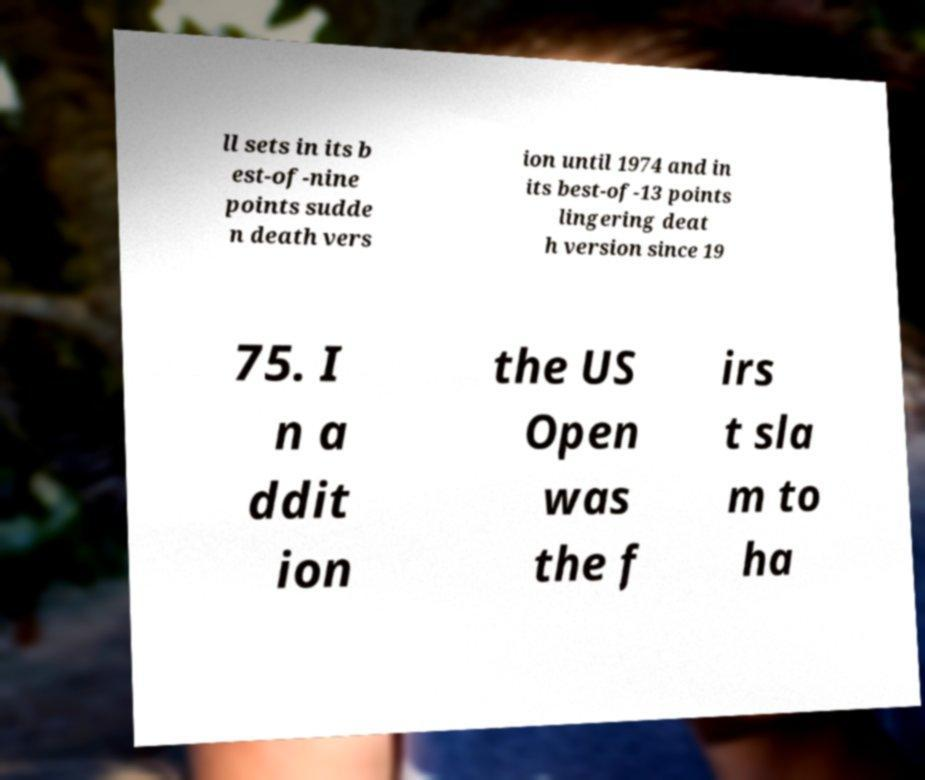For documentation purposes, I need the text within this image transcribed. Could you provide that? ll sets in its b est-of-nine points sudde n death vers ion until 1974 and in its best-of-13 points lingering deat h version since 19 75. I n a ddit ion the US Open was the f irs t sla m to ha 